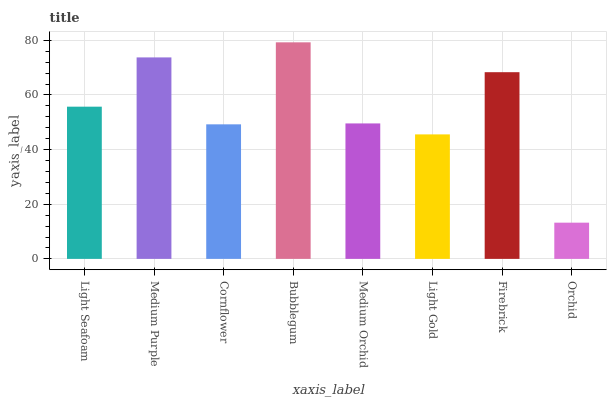Is Orchid the minimum?
Answer yes or no. Yes. Is Bubblegum the maximum?
Answer yes or no. Yes. Is Medium Purple the minimum?
Answer yes or no. No. Is Medium Purple the maximum?
Answer yes or no. No. Is Medium Purple greater than Light Seafoam?
Answer yes or no. Yes. Is Light Seafoam less than Medium Purple?
Answer yes or no. Yes. Is Light Seafoam greater than Medium Purple?
Answer yes or no. No. Is Medium Purple less than Light Seafoam?
Answer yes or no. No. Is Light Seafoam the high median?
Answer yes or no. Yes. Is Medium Orchid the low median?
Answer yes or no. Yes. Is Medium Purple the high median?
Answer yes or no. No. Is Light Gold the low median?
Answer yes or no. No. 